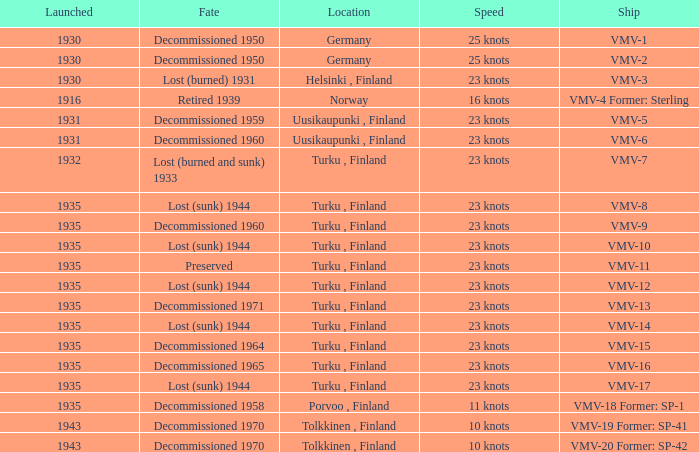What is the average launch date of the vmv-1 vessel in Germany? 1930.0. 